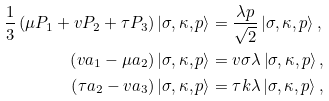Convert formula to latex. <formula><loc_0><loc_0><loc_500><loc_500>\frac { 1 } { 3 } \left ( \mu P _ { 1 } + v P _ { 2 } + \tau P _ { 3 } \right ) \left | \sigma , \kappa , p \right \rangle & = \frac { \lambda p } { \sqrt { 2 } } \left | \sigma , \kappa , p \right \rangle , \\ \left ( v a _ { 1 } - \mu a _ { 2 } \right ) \left | \sigma , \kappa , p \right \rangle & = v \sigma \lambda \left | \sigma , \kappa , p \right \rangle , \\ \left ( \tau a _ { 2 } - v a _ { 3 } \right ) \left | \sigma , \kappa , p \right \rangle & = \tau k \lambda \left | \sigma , \kappa , p \right \rangle ,</formula> 